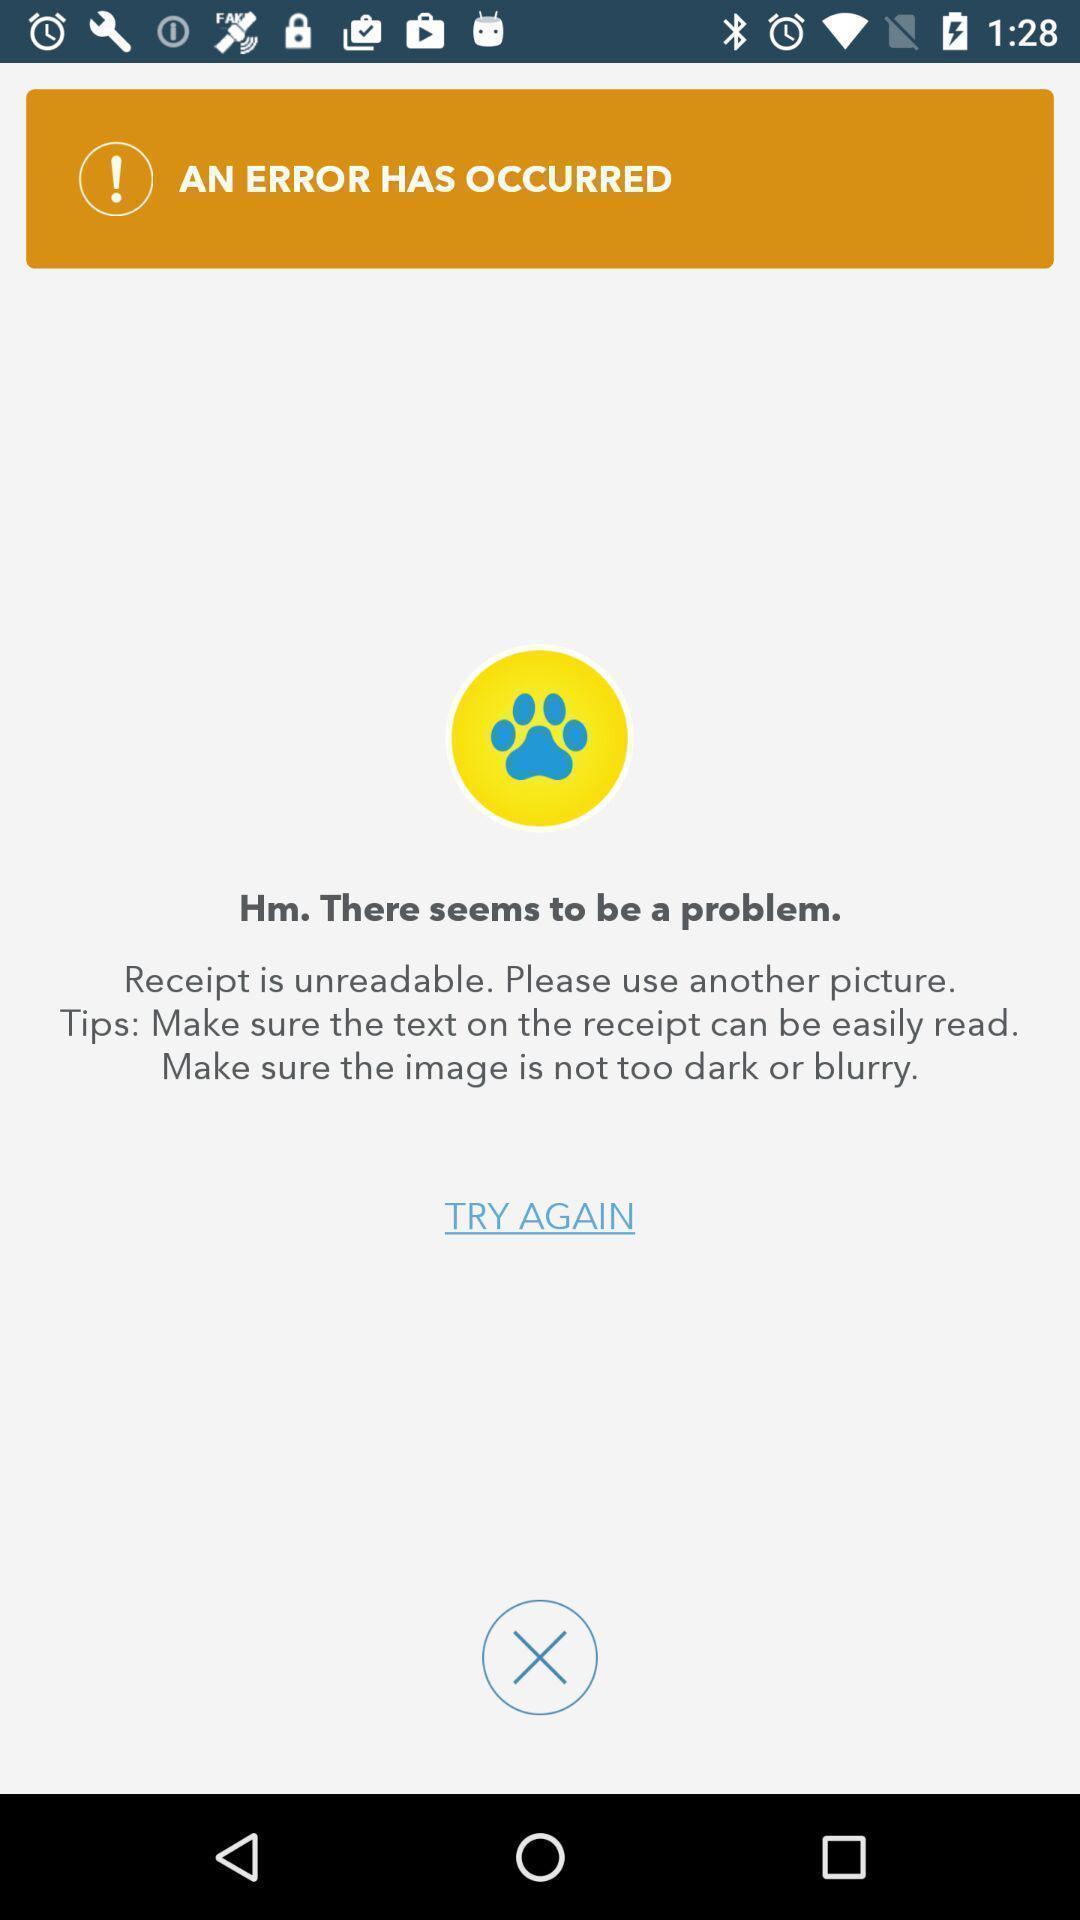Provide a description of this screenshot. Page shows the service application. 